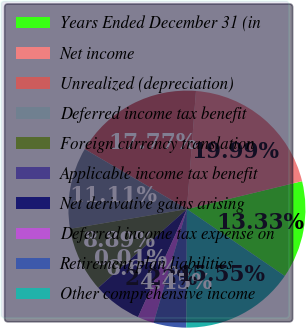Convert chart to OTSL. <chart><loc_0><loc_0><loc_500><loc_500><pie_chart><fcel>Years Ended December 31 (in<fcel>Net income<fcel>Unrealized (depreciation)<fcel>Deferred income tax benefit<fcel>Foreign currency translation<fcel>Applicable income tax benefit<fcel>Net derivative gains arising<fcel>Deferred income tax expense on<fcel>Retirement plan liabilities<fcel>Other comprehensive income<nl><fcel>13.33%<fcel>19.99%<fcel>17.77%<fcel>11.11%<fcel>8.89%<fcel>0.01%<fcel>6.67%<fcel>2.23%<fcel>4.45%<fcel>15.55%<nl></chart> 